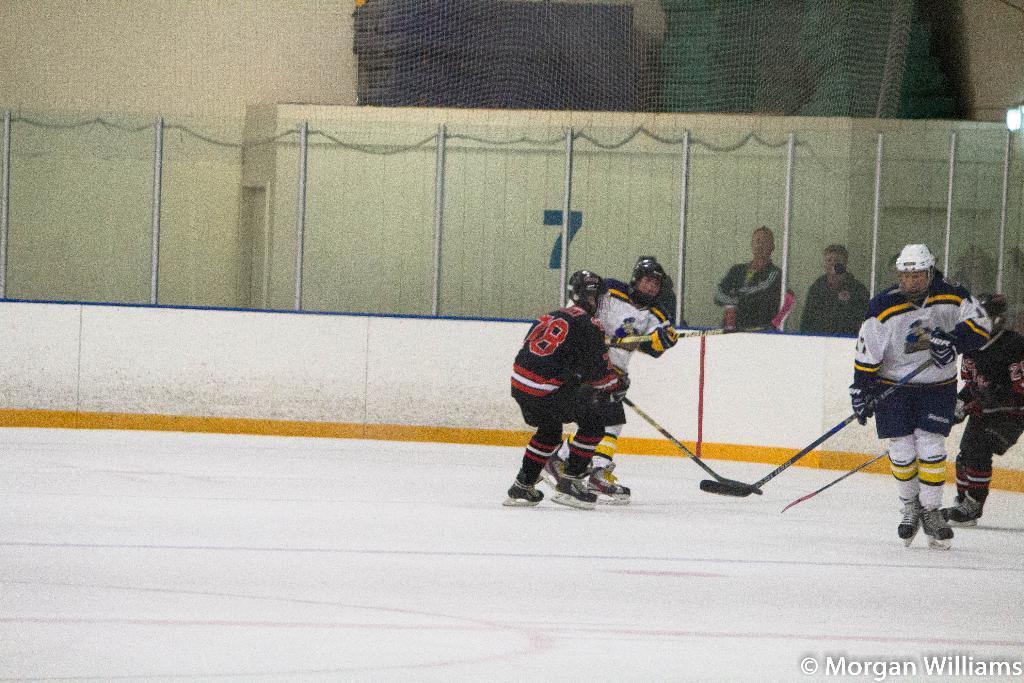Can you describe this image briefly? At the bottom of the image there is ice. In the middle of the image few people are doing skating and holding sticks and playing ice hockey. Behind them there is fencing. Behind the fencing few people are standing and watching. At the top of the image there is a wall. 